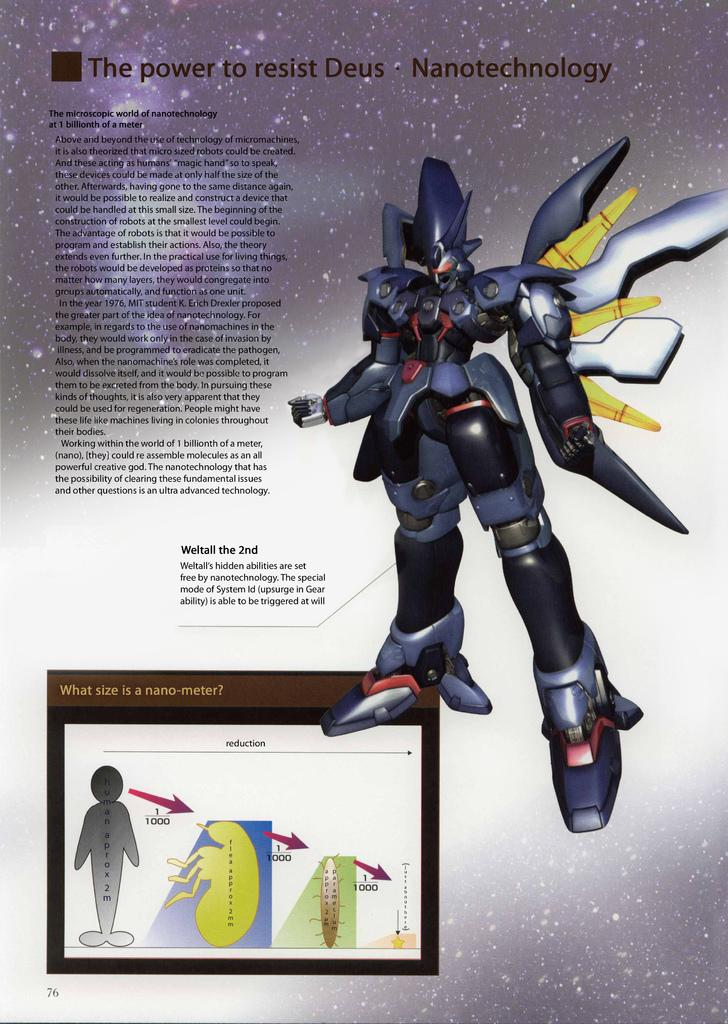What object can be seen on the right side of the image? There is a toy on the right side of the image. Where is the text located in the image? The text is on the left side of the image. What type of jeans is the cast wearing in the image? There is no cast or person wearing jeans present in the image. What time of day is depicted in the image? The time of day is not mentioned or depicted in the image. 